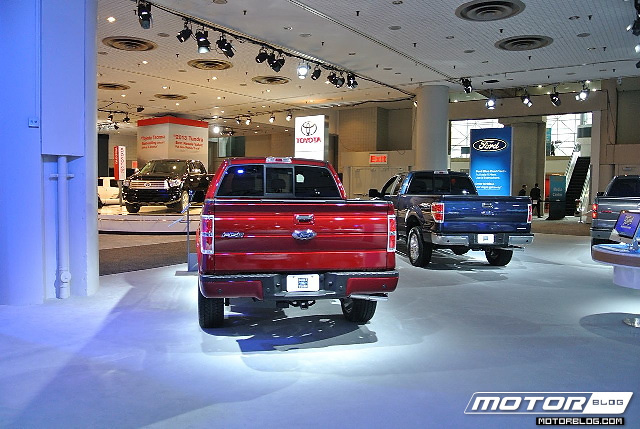Please identify all text content in this image. Sand Exit MOTOR BLOG MOTORELOG.COM 